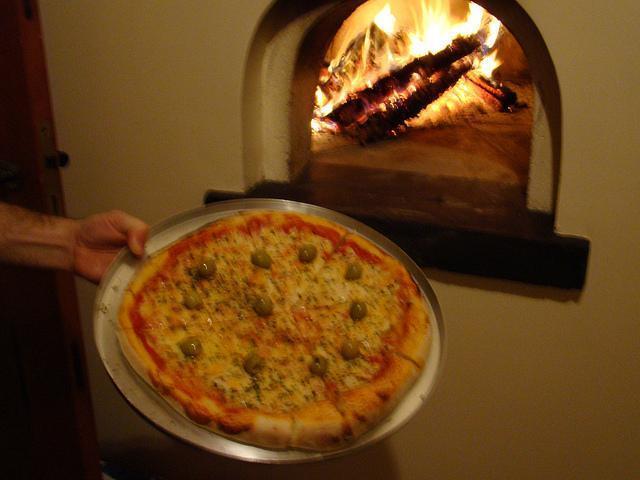How many pieces of pizza are shown?
Give a very brief answer. 8. How many pizzas are in the picture?
Give a very brief answer. 2. 